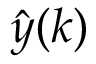<formula> <loc_0><loc_0><loc_500><loc_500>{ \hat { y } } ( k )</formula> 